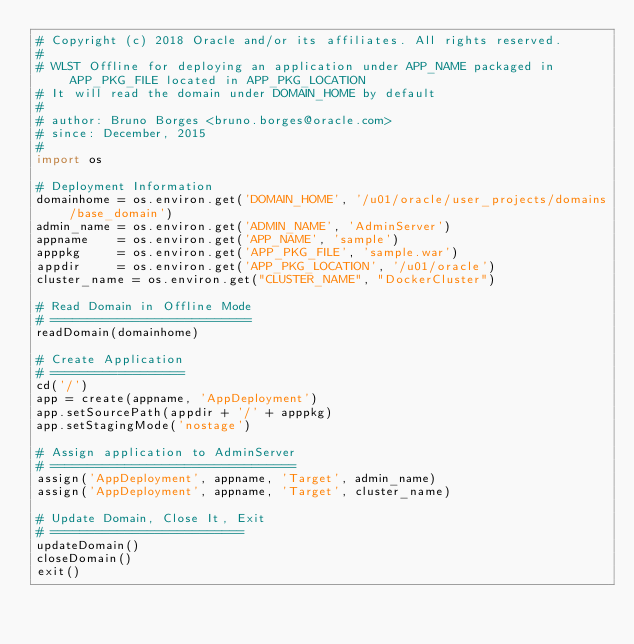<code> <loc_0><loc_0><loc_500><loc_500><_Python_># Copyright (c) 2018 Oracle and/or its affiliates. All rights reserved.
#
# WLST Offline for deploying an application under APP_NAME packaged in APP_PKG_FILE located in APP_PKG_LOCATION
# It will read the domain under DOMAIN_HOME by default
#
# author: Bruno Borges <bruno.borges@oracle.com>
# since: December, 2015
#
import os

# Deployment Information
domainhome = os.environ.get('DOMAIN_HOME', '/u01/oracle/user_projects/domains/base_domain')
admin_name = os.environ.get('ADMIN_NAME', 'AdminServer')
appname    = os.environ.get('APP_NAME', 'sample')
apppkg     = os.environ.get('APP_PKG_FILE', 'sample.war')
appdir     = os.environ.get('APP_PKG_LOCATION', '/u01/oracle')
cluster_name = os.environ.get("CLUSTER_NAME", "DockerCluster")

# Read Domain in Offline Mode
# ===========================
readDomain(domainhome)

# Create Application
# ==================
cd('/')
app = create(appname, 'AppDeployment')
app.setSourcePath(appdir + '/' + apppkg)
app.setStagingMode('nostage')

# Assign application to AdminServer
# =================================
assign('AppDeployment', appname, 'Target', admin_name)
assign('AppDeployment', appname, 'Target', cluster_name)

# Update Domain, Close It, Exit
# ==========================
updateDomain()
closeDomain()
exit()
</code> 